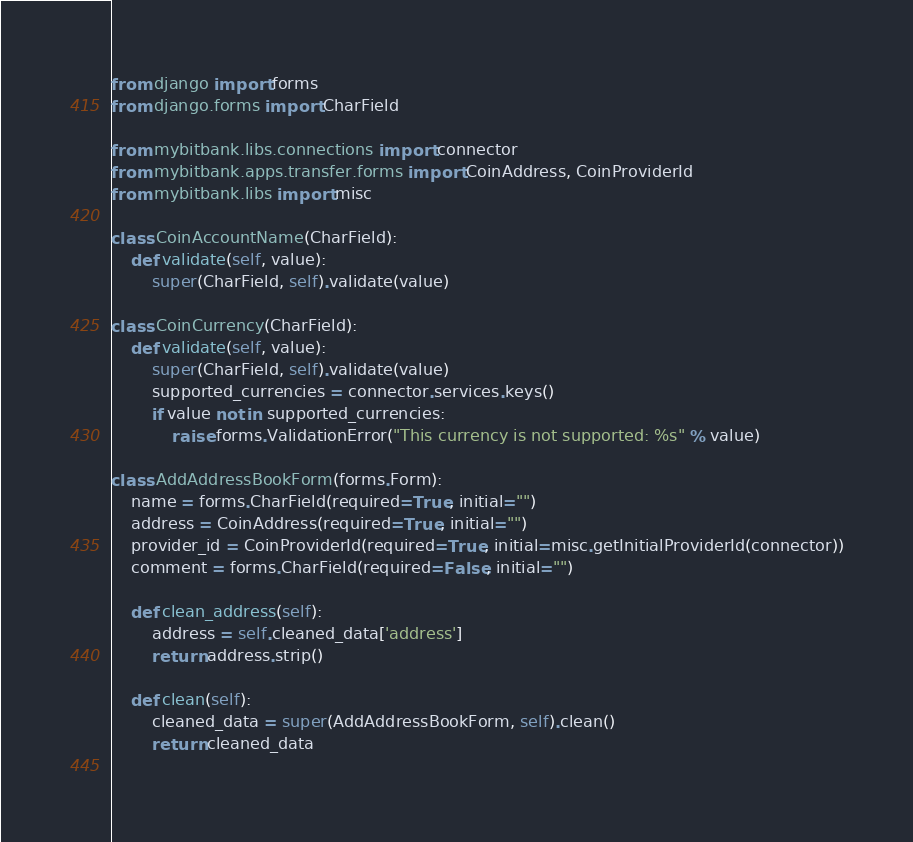Convert code to text. <code><loc_0><loc_0><loc_500><loc_500><_Python_>from django import forms
from django.forms import CharField

from mybitbank.libs.connections import connector
from mybitbank.apps.transfer.forms import CoinAddress, CoinProviderId
from mybitbank.libs import misc

class CoinAccountName(CharField):
    def validate(self, value):
        super(CharField, self).validate(value)

class CoinCurrency(CharField):
    def validate(self, value):
        super(CharField, self).validate(value)
        supported_currencies = connector.services.keys()
        if value not in supported_currencies:
            raise forms.ValidationError("This currency is not supported: %s" % value)

class AddAddressBookForm(forms.Form):
    name = forms.CharField(required=True, initial="")
    address = CoinAddress(required=True, initial="")
    provider_id = CoinProviderId(required=True, initial=misc.getInitialProviderId(connector))
    comment = forms.CharField(required=False, initial="")

    def clean_address(self):
        address = self.cleaned_data['address']
        return address.strip()
    
    def clean(self):
        cleaned_data = super(AddAddressBookForm, self).clean()
        return cleaned_data
    
</code> 